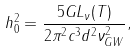<formula> <loc_0><loc_0><loc_500><loc_500>h _ { 0 } ^ { 2 } = \frac { 5 G L _ { \nu } ( T ) } { 2 \pi ^ { 2 } c ^ { 3 } d ^ { 2 } \nu _ { G W } ^ { 2 } } ,</formula> 